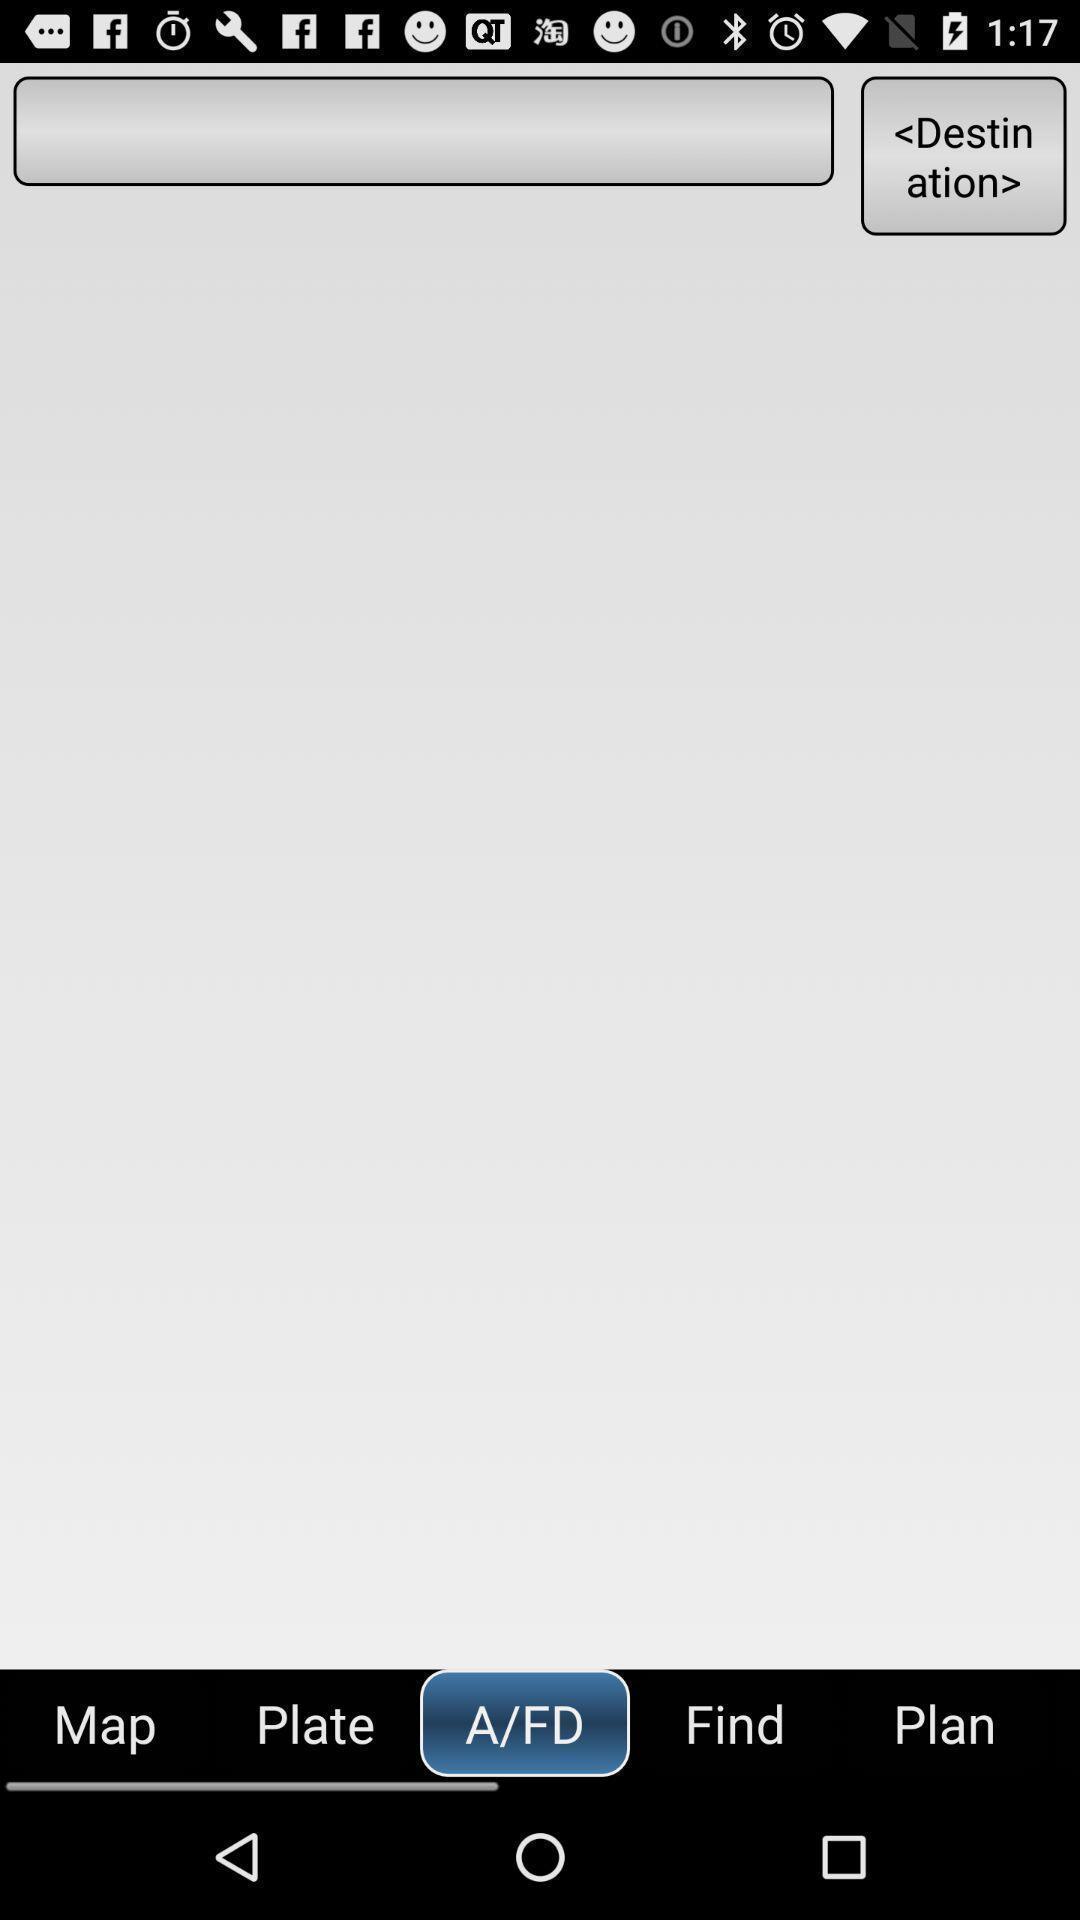Please provide a description for this image. Page for searching destination location. 